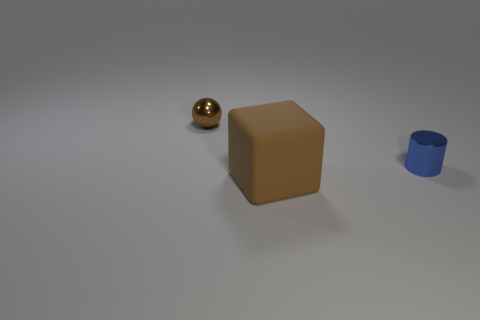Is the material of the small object that is on the left side of the rubber block the same as the large object in front of the metal cylinder?
Ensure brevity in your answer.  No. Is the number of small objects to the left of the brown block less than the number of large red metallic cylinders?
Your answer should be very brief. No. Is there anything else that has the same shape as the rubber thing?
Your response must be concise. No. There is a metallic thing that is on the right side of the brown metal object; is it the same size as the large brown rubber thing?
Your answer should be compact. No. How big is the metal thing in front of the tiny object that is to the left of the small cylinder?
Offer a terse response. Small. Is the brown sphere made of the same material as the tiny thing right of the large brown block?
Provide a short and direct response. Yes. Are there fewer small blue metallic objects that are on the left side of the brown rubber object than balls to the left of the small blue metal cylinder?
Provide a short and direct response. Yes. There is another tiny thing that is the same material as the blue object; what color is it?
Give a very brief answer. Brown. There is a brown object that is in front of the tiny cylinder; are there any matte objects that are on the left side of it?
Provide a succinct answer. No. What color is the shiny sphere that is the same size as the blue metal thing?
Your response must be concise. Brown. 